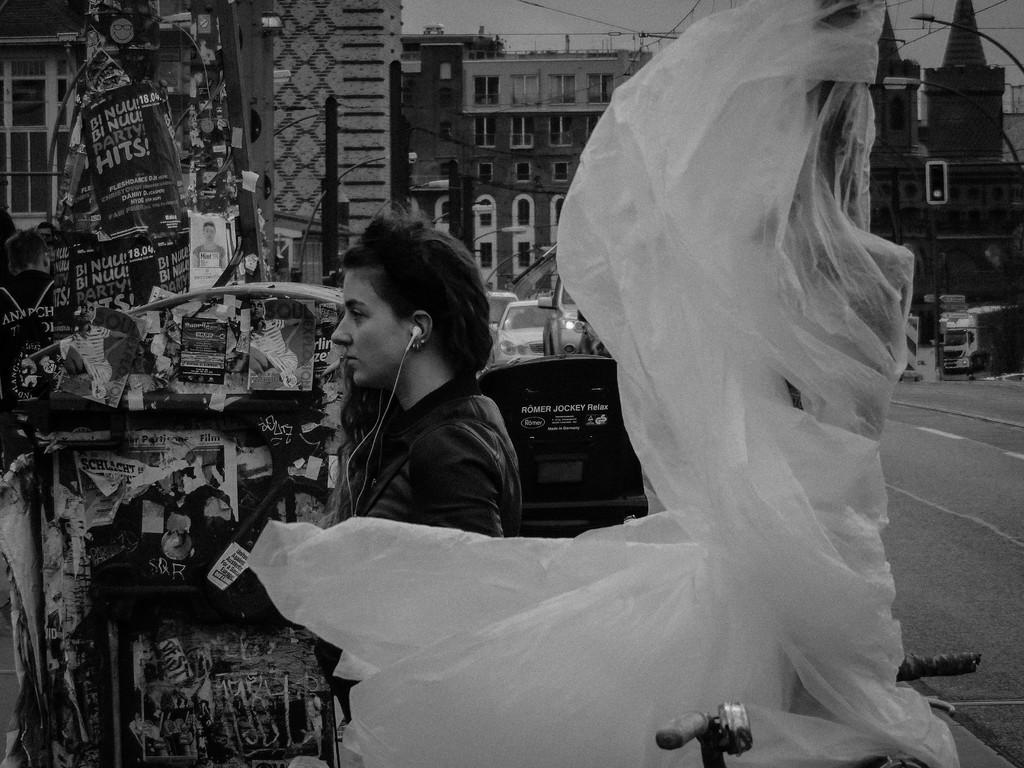What is the color scheme of the image? The image is black and white. Who is present in the image? There is a woman in the image. What is covering the right side of the woman? There is a cover on the right side of the woman. What can be seen in the background of the image? There are buildings, poles, and the sky visible in the background of the image. What type of vest is the woman wearing in the image? There is no vest visible in the image; the woman is covered by a cover on the right side. Can you see any chalk drawings on the ground in the image? There is no mention of chalk or drawings on the ground in the provided facts, so it cannot be determined from the image. 